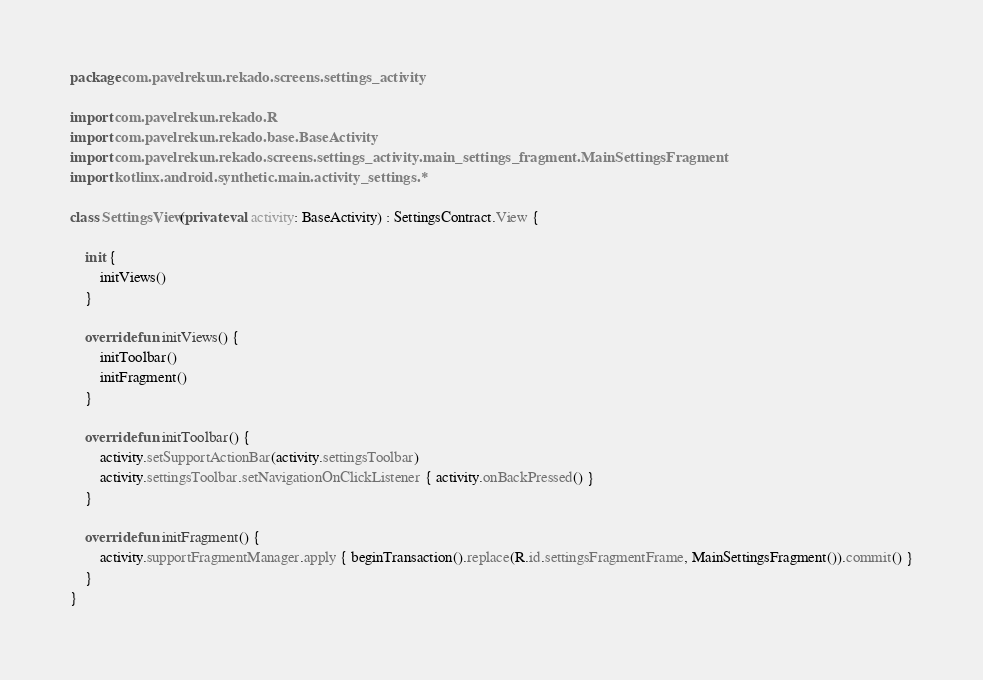Convert code to text. <code><loc_0><loc_0><loc_500><loc_500><_Kotlin_>package com.pavelrekun.rekado.screens.settings_activity

import com.pavelrekun.rekado.R
import com.pavelrekun.rekado.base.BaseActivity
import com.pavelrekun.rekado.screens.settings_activity.main_settings_fragment.MainSettingsFragment
import kotlinx.android.synthetic.main.activity_settings.*

class SettingsView(private val activity: BaseActivity) : SettingsContract.View {

    init {
        initViews()
    }

    override fun initViews() {
        initToolbar()
        initFragment()
    }

    override fun initToolbar() {
        activity.setSupportActionBar(activity.settingsToolbar)
        activity.settingsToolbar.setNavigationOnClickListener { activity.onBackPressed() }
    }

    override fun initFragment() {
        activity.supportFragmentManager.apply { beginTransaction().replace(R.id.settingsFragmentFrame, MainSettingsFragment()).commit() }
    }
}</code> 